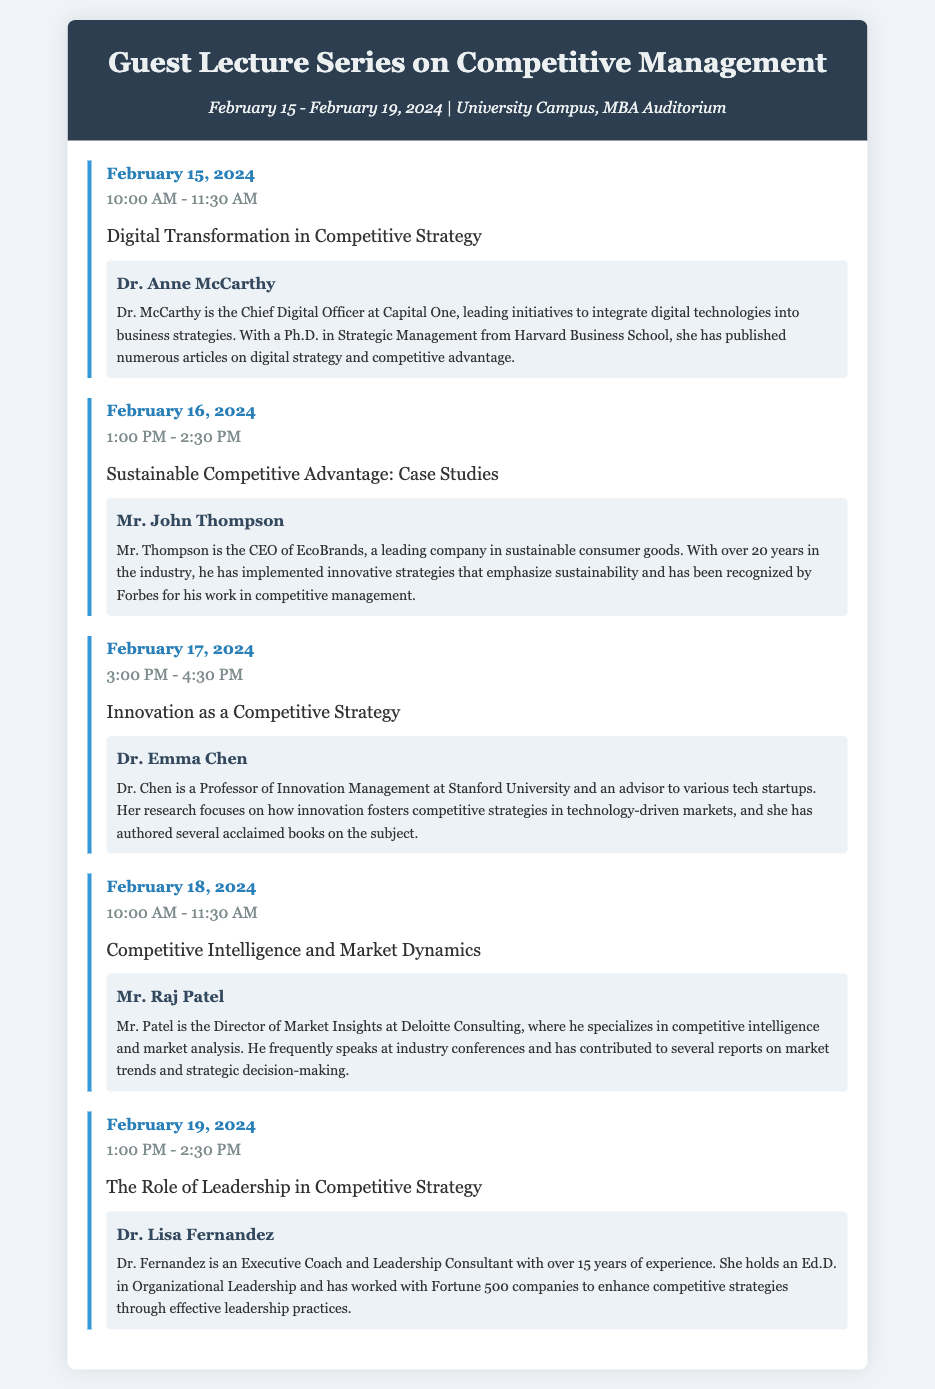What is the date range for the guest lecture series? The date range for the guest lecture series is indicated at the top of the document, which is February 15 - February 19, 2024.
Answer: February 15 - February 19, 2024 Who is the speaker for the session on Digital Transformation in Competitive Strategy? The speaker for this session is mentioned directly under the session topic, which is Dr. Anne McCarthy.
Answer: Dr. Anne McCarthy What is the main topic covered on February 16, 2024? The main topic for this date is stated clearly in the session section as "Sustainable Competitive Advantage: Case Studies."
Answer: Sustainable Competitive Advantage: Case Studies Which session focuses on the role of leadership? The session focusing on leadership is identified by the session topic listed on February 19, 2024, which is "The Role of Leadership in Competitive Strategy."
Answer: The Role of Leadership in Competitive Strategy How many sessions are scheduled for the guest lecture series? The total number of sessions is derived from counting the sessions listed in the agenda, which totals five sessions.
Answer: 5 What time does the session on Competitive Intelligence and Market Dynamics start? The start time for this session is provided in the session's time detail, which states 10:00 AM - 11:30 AM.
Answer: 10:00 AM What is Dr. Lisa Fernandez's area of expertise? Dr. Lisa Fernandez's area of expertise is mentioned in her bio, which refers to her work as an Executive Coach and Leadership Consultant.
Answer: Executive Coach and Leadership Consultant Which speaker has a Ph.D. in Strategic Management? The document explicitly states that Dr. Anne McCarthy has a Ph.D. in Strategic Management, based in her bio.
Answer: Dr. Anne McCarthy 